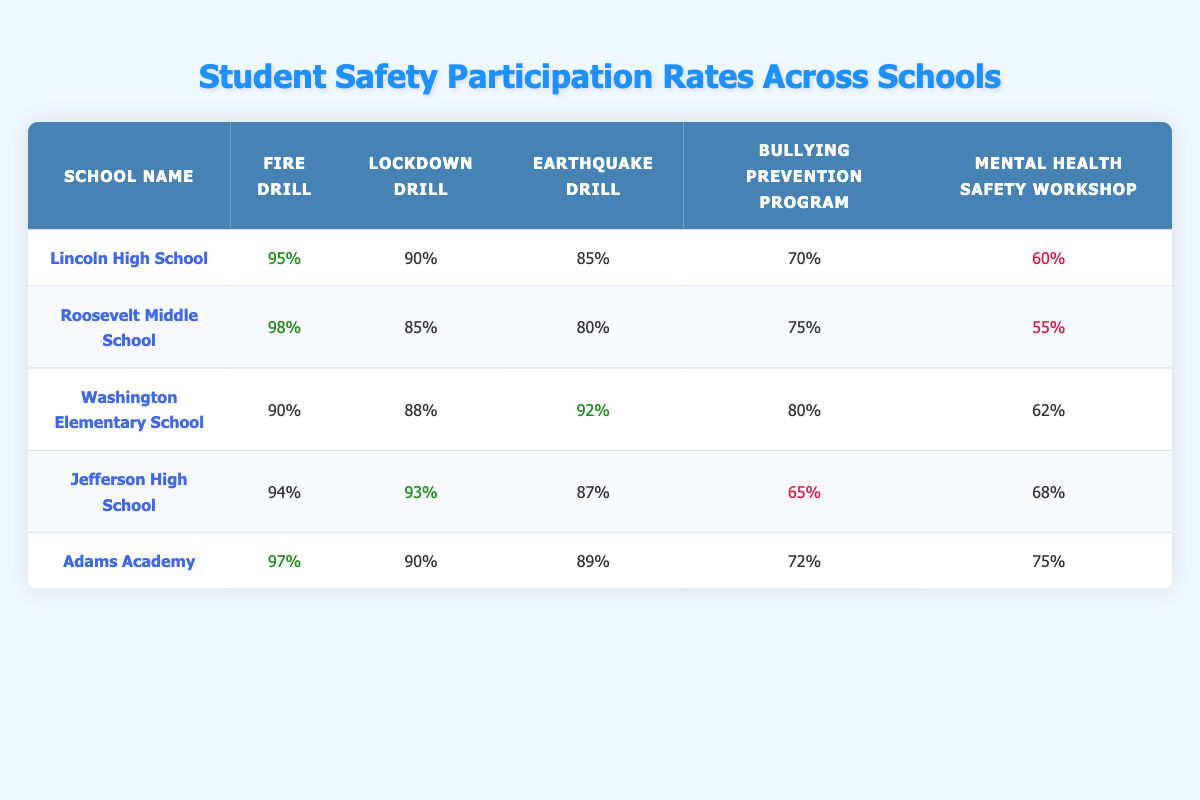What is the fire drill participation rate for Roosevelt Middle School? Roosevelt Middle School has a fire drill participation rate listed in the table as 98%.
Answer: 98% Which school has the highest fire drill participation rate? By comparing the fire drill participation rates of all schools, Roosevelt Middle School has the highest rate at 98%.
Answer: Roosevelt Middle School What is the average participation rate for the mental health safety workshop across all schools? To find the average, sum the participation rates: 60 + 55 + 62 + 68 + 75 = 320, then divide by 5 schools: 320 / 5 = 64.
Answer: 64% True or False: Washington Elementary School has a higher participation rate in bullying prevention programs than Jefferson High School. Washington Elementary School has a rate of 80%, while Jefferson High School's rate is 65%. Therefore, the statement is true.
Answer: True What is the difference in participation rates for the lockdown drill between Lincoln High School and Adams Academy? Lincoln High School has a lockdown drill participation rate of 90%, while Adams Academy has a rate of 90%. Therefore, the difference is 90% - 90% = 0%.
Answer: 0% Which school has the lowest participation rate in the mental health safety workshop, and what is that rate? By examining the mental health safety workshop rates, Roosevelt Middle School has the lowest participation rate at 55%.
Answer: Roosevelt Middle School, 55% What is the total participation rate for all safety drills (fire, lockdown, earthquake) for Lincoln High School? For Lincoln High School, the fire drill rate is 95%, lockdown is 90%, and earthquake is 85%. The total is 95 + 90 + 85 = 270.
Answer: 270% How does the earthquake drill participation rate of Adams Academy compare to that of Jefferson High School? Adams Academy has an earthquake drill participation rate of 89%, while Jefferson High School has a rate of 87%. Therefore, Adams Academy has a higher rate by 2%.
Answer: Adams Academy has a 2% higher rate What percentage of schools have a bullying prevention program participation rate below 70%? The schools with rates below 70% are Lincoln High School (70%), and Jefferson High School (65%). Out of 5 schools, that's 1 out of 5, giving us 1 / 5 = 20%.
Answer: 20% Which school has the highest overall participation rate across all compared safety drills and programs? To find this, we can calculate the average participation rates for each school for all drills and programs. After calculation, Adams Academy has the highest average participation rate.
Answer: Adams Academy 